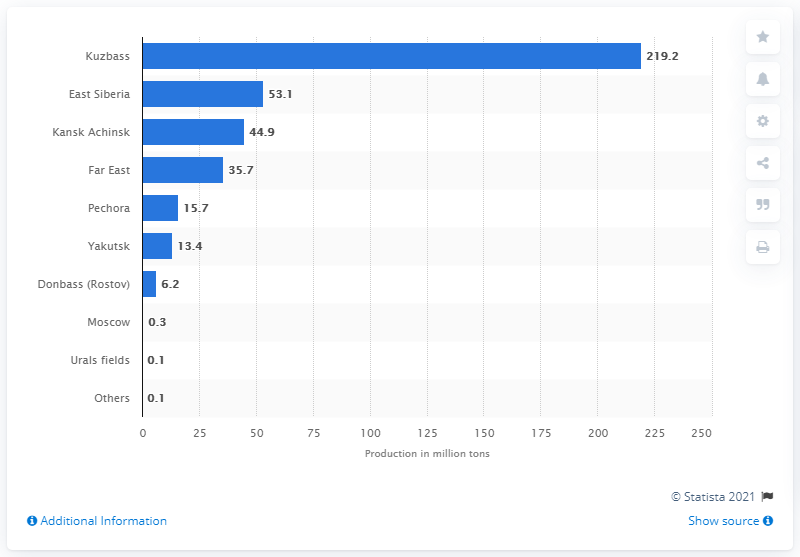Mention a couple of crucial points in this snapshot. In 2012, East Siberia produced 53.1 million short tons of coal. 